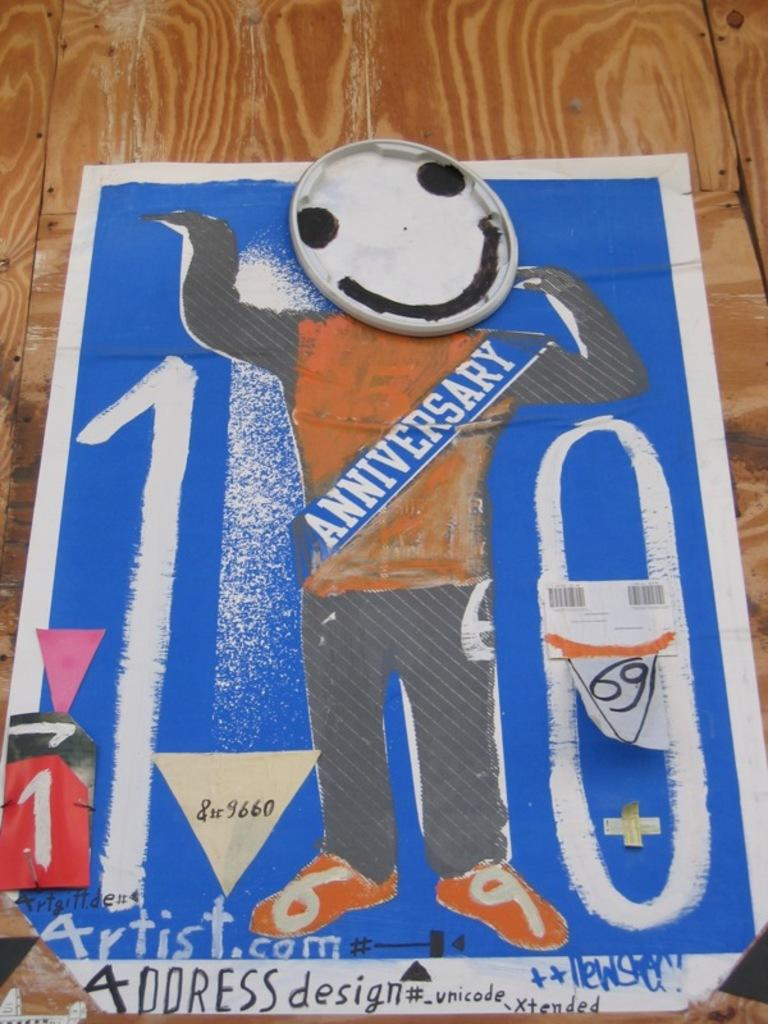What is featured in the image? There is a poster in the image. What colors are present on the poster? The poster has blue, black, white, and orange colors. What is the poster placed on? The poster is on a wooden surface. What colors are visible on the wooden surface? The wooden surface is brown and cream in color. Can you see a friend holding a zebra and a goldfish in the image? No, there is no friend, zebra, or goldfish present in the image. The image only features a poster on a wooden surface. 